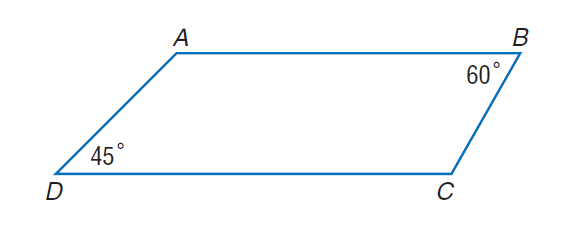Question: Given figure A B C D, with A B \parallel D C, m \angle B = 60, m \angle D = 45, B C = 8 and A B = 24, find the perimeter.
Choices:
A. 26 + 2 \sqrt { 3 } + 2 \sqrt { 6 }
B. 26 + 4 \sqrt { 3 } + 4 \sqrt { 6 }
C. 52 + 2 \sqrt { 3 } + 2 \sqrt { 6 }
D. 52 + 4 \sqrt { 3 } + 4 \sqrt { 6 }
Answer with the letter. Answer: D 